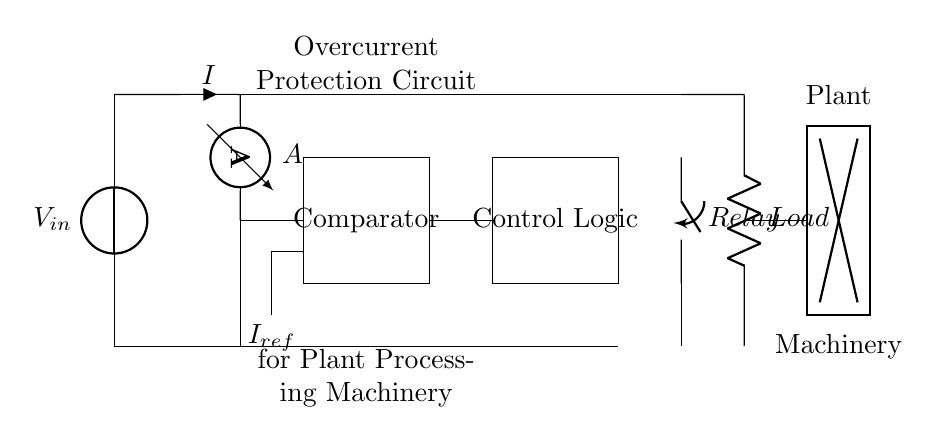What is the input voltage of the circuit? The input voltage is labeled as V_subscript_in in the circuit, indicating the source voltage supplied to the circuit.
Answer: V_in What does the ammeter measure in this circuit? The ammeter is positioned in series with the load; thus, it measures the current flowing through the circuit.
Answer: Current What is the role of the comparator? The comparator compares the current flowing in the circuit, measured by the ammeter, to a reference current set by I_subscript_ref. It determines whether the actual current exceeds the reference level.
Answer: Overcurrent detection What component actuates the relay? The control logic, located next to the comparator, processes the comparison results and sends a signal to actuate the relay, thereby controlling its state based on the current measurement.
Answer: Control logic What happens when the current exceeds the reference level? When the current exceeds the reference level, the comparator sends a signal to the control logic, which then activates the relay to disconnect the load, thus preventing damage to the machinery.
Answer: Relay opens What type of protection does this circuit provide? This circuit provides overcurrent protection by disconnecting the load when the current exceeds a predefined limit, safeguarding the machinery from potential damage.
Answer: Overcurrent protection What is the load in this circuit? The load is an electrical component indicated as "Load" in the circuit diagram; it represents the plant processing machinery that requires power.
Answer: Plant machinery 